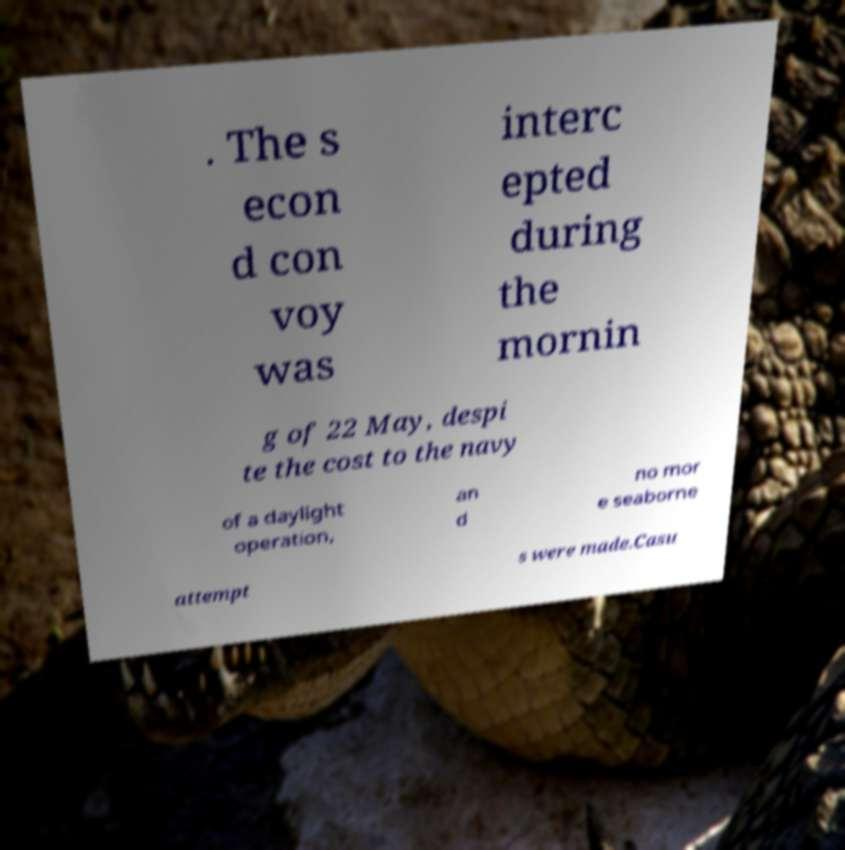There's text embedded in this image that I need extracted. Can you transcribe it verbatim? . The s econ d con voy was interc epted during the mornin g of 22 May, despi te the cost to the navy of a daylight operation, an d no mor e seaborne attempt s were made.Casu 